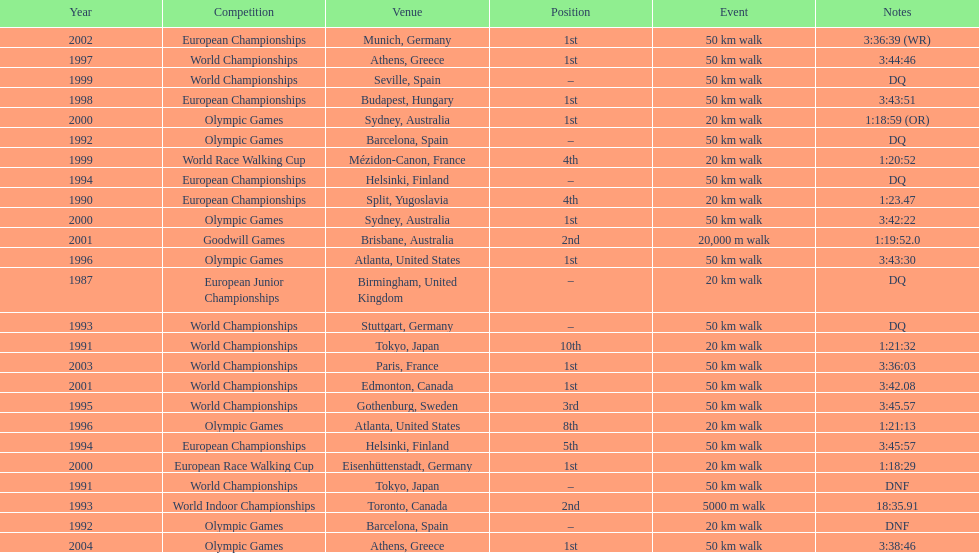How long did it take to walk 50 km in the 2004 olympic games? 3:38:46. 